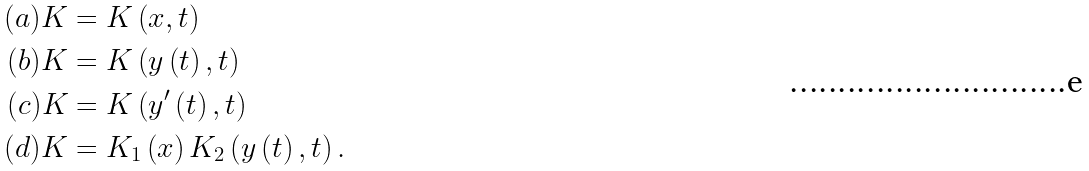Convert formula to latex. <formula><loc_0><loc_0><loc_500><loc_500>( a ) K & = K \left ( x , t \right ) \\ ( b ) K & = K \left ( y \left ( t \right ) , t \right ) \\ ( c ) K & = K \left ( y ^ { \prime } \left ( t \right ) , t \right ) \\ ( d ) K & = K _ { 1 } \left ( x \right ) K _ { 2 } \left ( y \left ( t \right ) , t \right ) .</formula> 